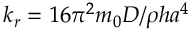<formula> <loc_0><loc_0><loc_500><loc_500>k _ { r } = 1 6 \pi ^ { 2 } m _ { 0 } D / \rho h a ^ { 4 }</formula> 